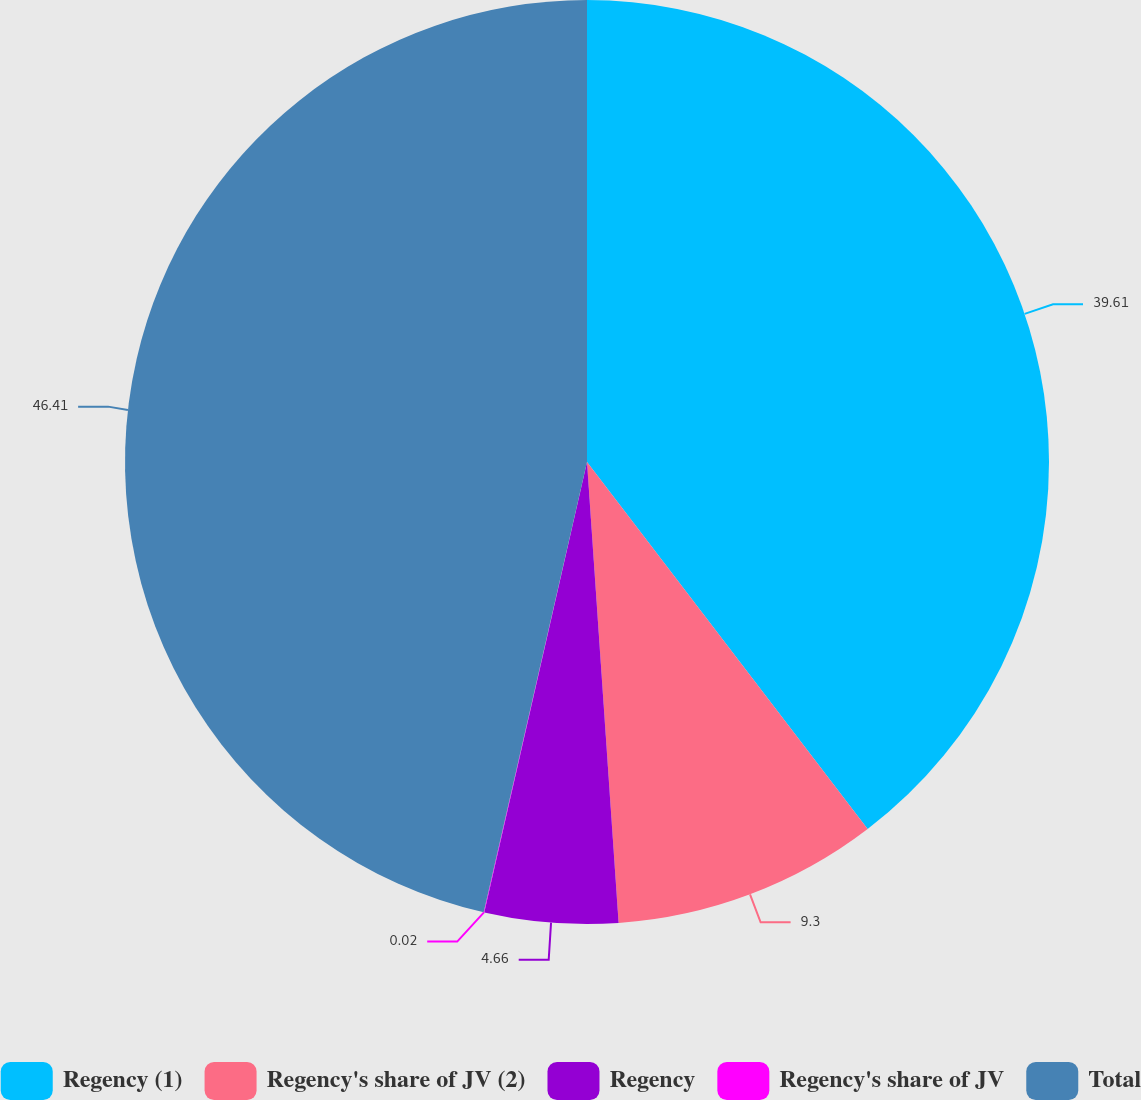Convert chart to OTSL. <chart><loc_0><loc_0><loc_500><loc_500><pie_chart><fcel>Regency (1)<fcel>Regency's share of JV (2)<fcel>Regency<fcel>Regency's share of JV<fcel>Total<nl><fcel>39.61%<fcel>9.3%<fcel>4.66%<fcel>0.02%<fcel>46.41%<nl></chart> 